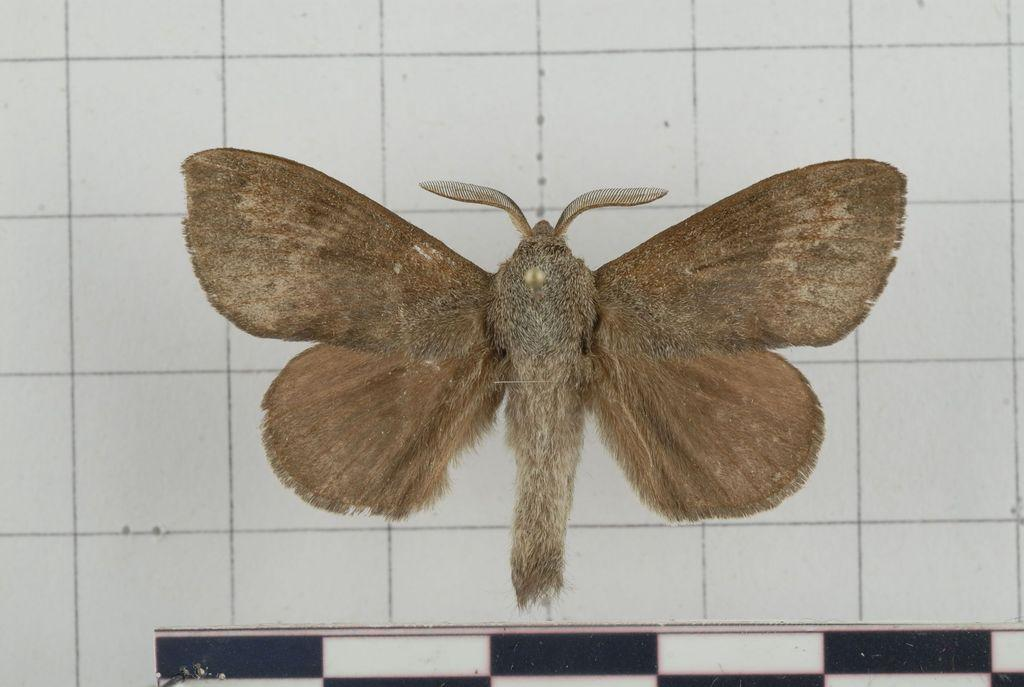What is present on the white surface in the image? There is a fly on the white surface in the image. Can you describe the color of the fly? The color of the fly cannot be determined from the image. What is the background of the image? The background of the image is not mentioned, but the fly is on a white surface. How many dogs are wearing jeans in the image? There are no dogs or jeans present in the image; it only features a fly on a white surface. 